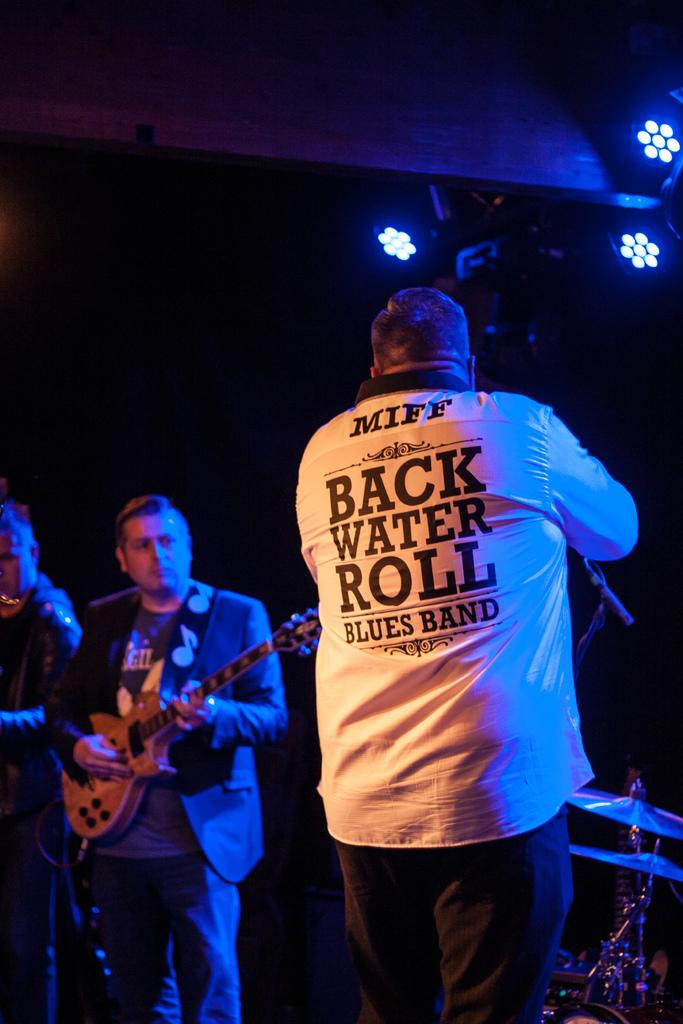How many people are in the image? There are three persons in the image. What are the persons in the image doing? The persons are playing musical instruments. What type of attraction can be seen in the image? There is no attraction present in the image; it features three persons playing musical instruments. What color is the hair of the person on the left in the image? There is no information about the color of the persons' hair in the image. 